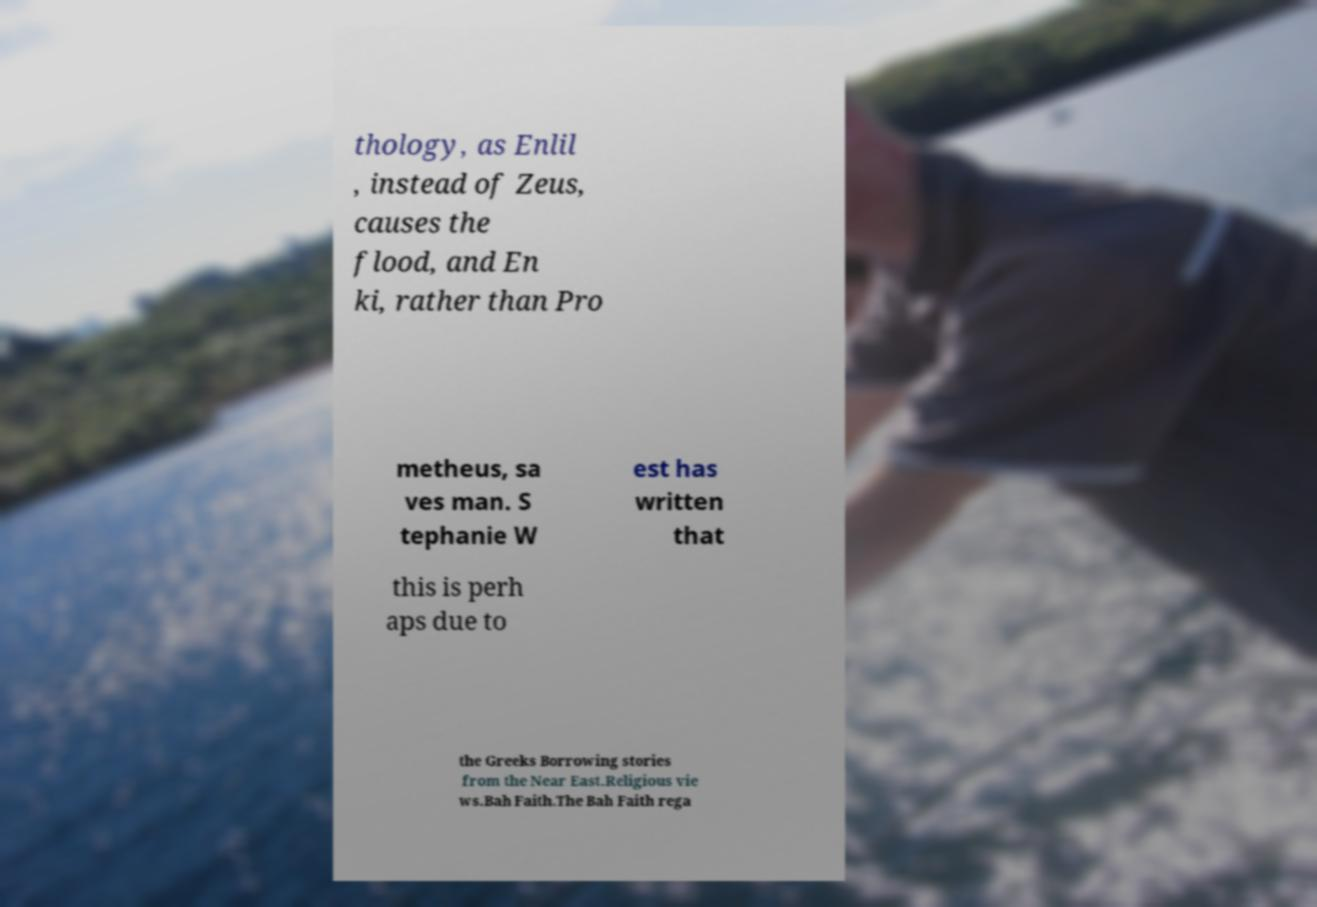Can you accurately transcribe the text from the provided image for me? thology, as Enlil , instead of Zeus, causes the flood, and En ki, rather than Pro metheus, sa ves man. S tephanie W est has written that this is perh aps due to the Greeks Borrowing stories from the Near East.Religious vie ws.Bah Faith.The Bah Faith rega 